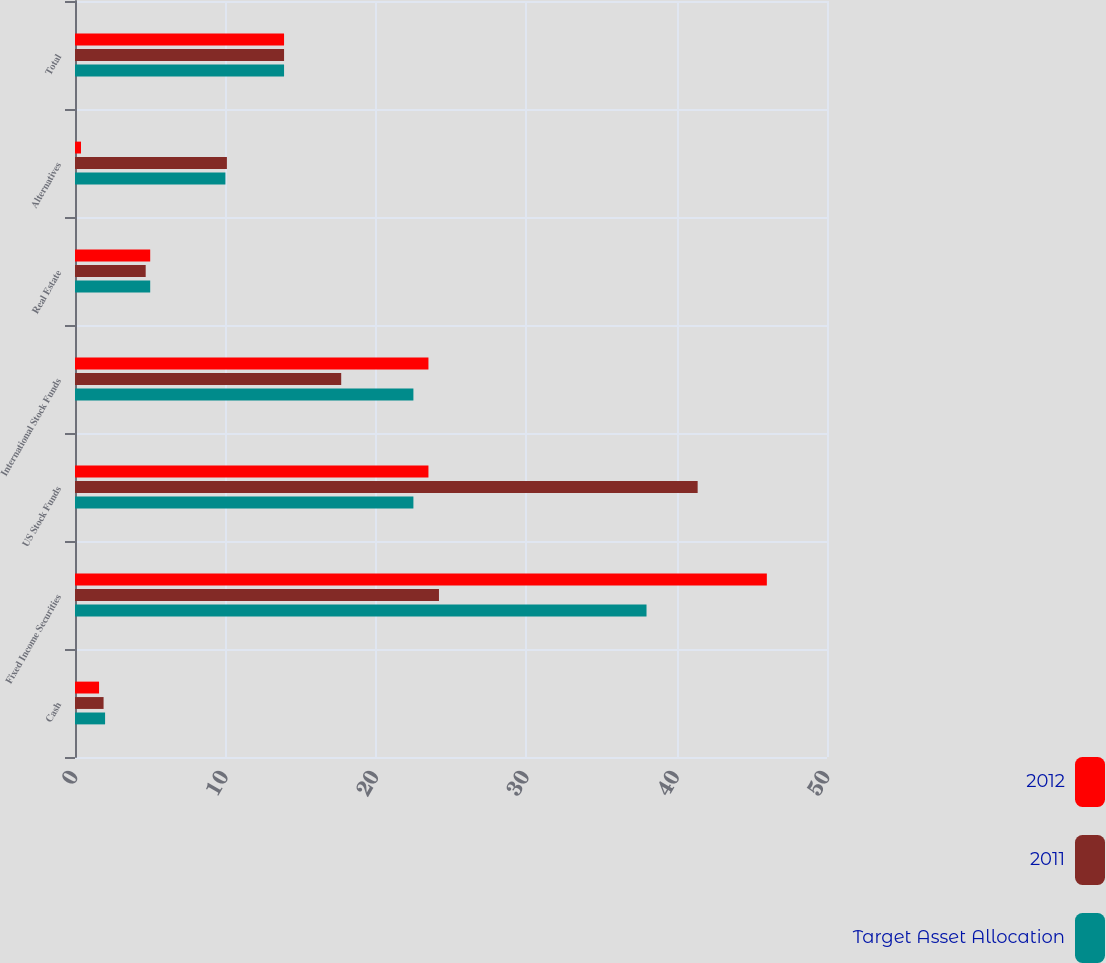Convert chart. <chart><loc_0><loc_0><loc_500><loc_500><stacked_bar_chart><ecel><fcel>Cash<fcel>Fixed Income Securities<fcel>US Stock Funds<fcel>International Stock Funds<fcel>Real Estate<fcel>Alternatives<fcel>Total<nl><fcel>2012<fcel>1.6<fcel>46<fcel>23.5<fcel>23.5<fcel>5<fcel>0.4<fcel>13.9<nl><fcel>2011<fcel>1.9<fcel>24.2<fcel>41.4<fcel>17.7<fcel>4.7<fcel>10.1<fcel>13.9<nl><fcel>Target Asset Allocation<fcel>2<fcel>38<fcel>22.5<fcel>22.5<fcel>5<fcel>10<fcel>13.9<nl></chart> 